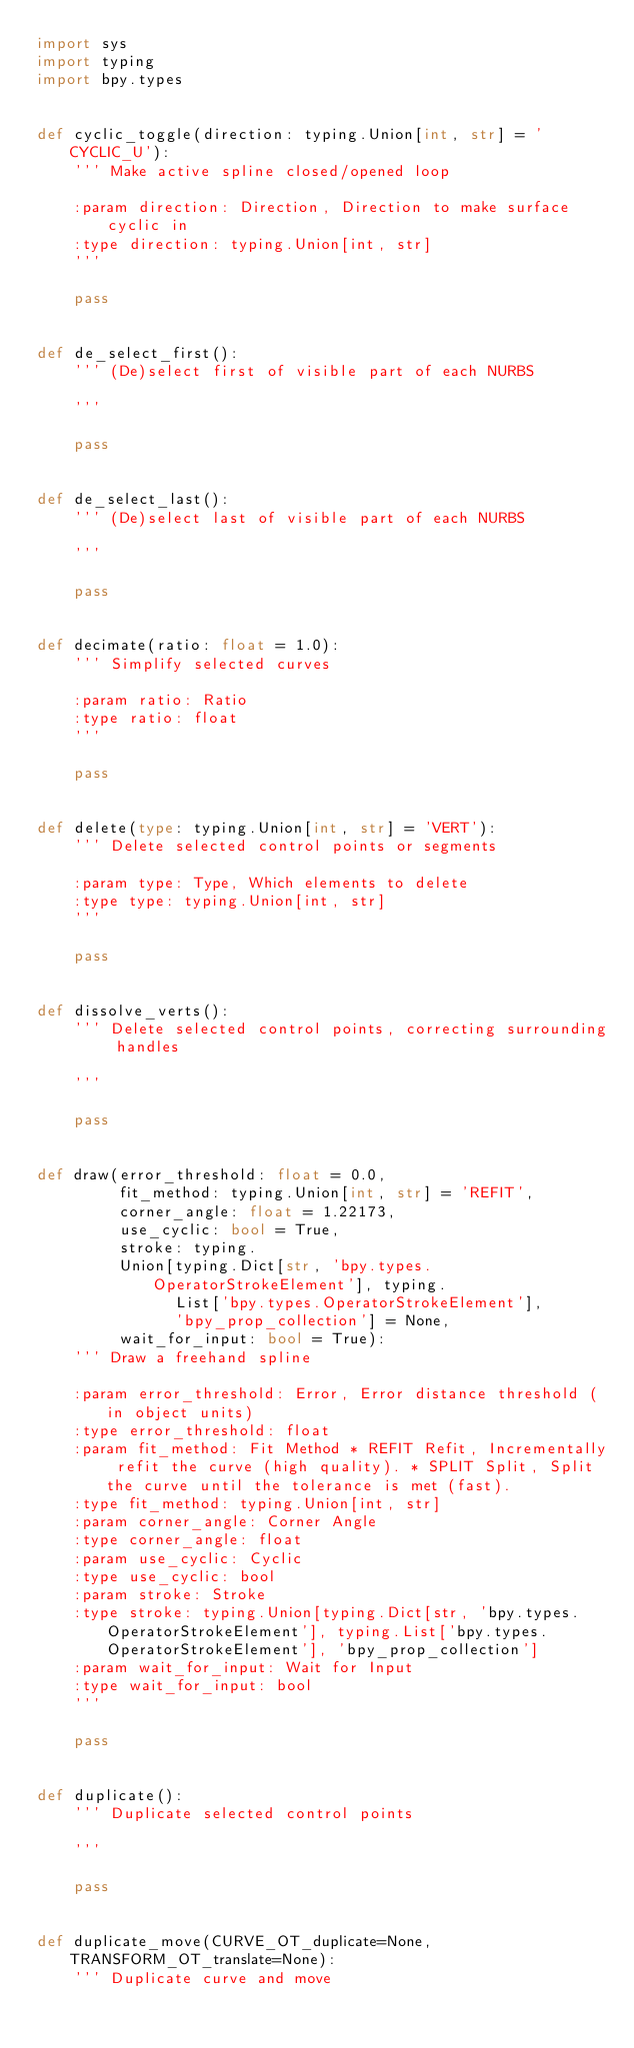Convert code to text. <code><loc_0><loc_0><loc_500><loc_500><_Python_>import sys
import typing
import bpy.types


def cyclic_toggle(direction: typing.Union[int, str] = 'CYCLIC_U'):
    ''' Make active spline closed/opened loop

    :param direction: Direction, Direction to make surface cyclic in
    :type direction: typing.Union[int, str]
    '''

    pass


def de_select_first():
    ''' (De)select first of visible part of each NURBS

    '''

    pass


def de_select_last():
    ''' (De)select last of visible part of each NURBS

    '''

    pass


def decimate(ratio: float = 1.0):
    ''' Simplify selected curves

    :param ratio: Ratio
    :type ratio: float
    '''

    pass


def delete(type: typing.Union[int, str] = 'VERT'):
    ''' Delete selected control points or segments

    :param type: Type, Which elements to delete
    :type type: typing.Union[int, str]
    '''

    pass


def dissolve_verts():
    ''' Delete selected control points, correcting surrounding handles

    '''

    pass


def draw(error_threshold: float = 0.0,
         fit_method: typing.Union[int, str] = 'REFIT',
         corner_angle: float = 1.22173,
         use_cyclic: bool = True,
         stroke: typing.
         Union[typing.Dict[str, 'bpy.types.OperatorStrokeElement'], typing.
               List['bpy.types.OperatorStrokeElement'],
               'bpy_prop_collection'] = None,
         wait_for_input: bool = True):
    ''' Draw a freehand spline

    :param error_threshold: Error, Error distance threshold (in object units)
    :type error_threshold: float
    :param fit_method: Fit Method * REFIT Refit, Incrementally refit the curve (high quality). * SPLIT Split, Split the curve until the tolerance is met (fast).
    :type fit_method: typing.Union[int, str]
    :param corner_angle: Corner Angle
    :type corner_angle: float
    :param use_cyclic: Cyclic
    :type use_cyclic: bool
    :param stroke: Stroke
    :type stroke: typing.Union[typing.Dict[str, 'bpy.types.OperatorStrokeElement'], typing.List['bpy.types.OperatorStrokeElement'], 'bpy_prop_collection']
    :param wait_for_input: Wait for Input
    :type wait_for_input: bool
    '''

    pass


def duplicate():
    ''' Duplicate selected control points

    '''

    pass


def duplicate_move(CURVE_OT_duplicate=None, TRANSFORM_OT_translate=None):
    ''' Duplicate curve and move
</code> 